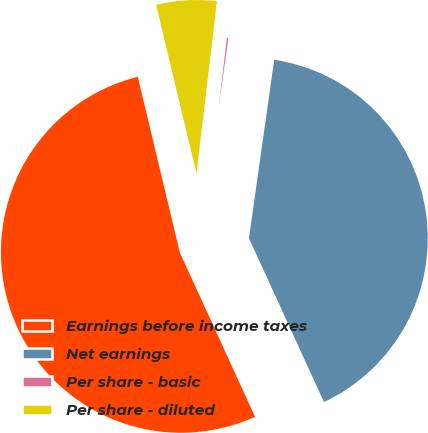Convert chart to OTSL. <chart><loc_0><loc_0><loc_500><loc_500><pie_chart><fcel>Earnings before income taxes<fcel>Net earnings<fcel>Per share - basic<fcel>Per share - diluted<nl><fcel>53.1%<fcel>40.9%<fcel>0.36%<fcel>5.63%<nl></chart> 